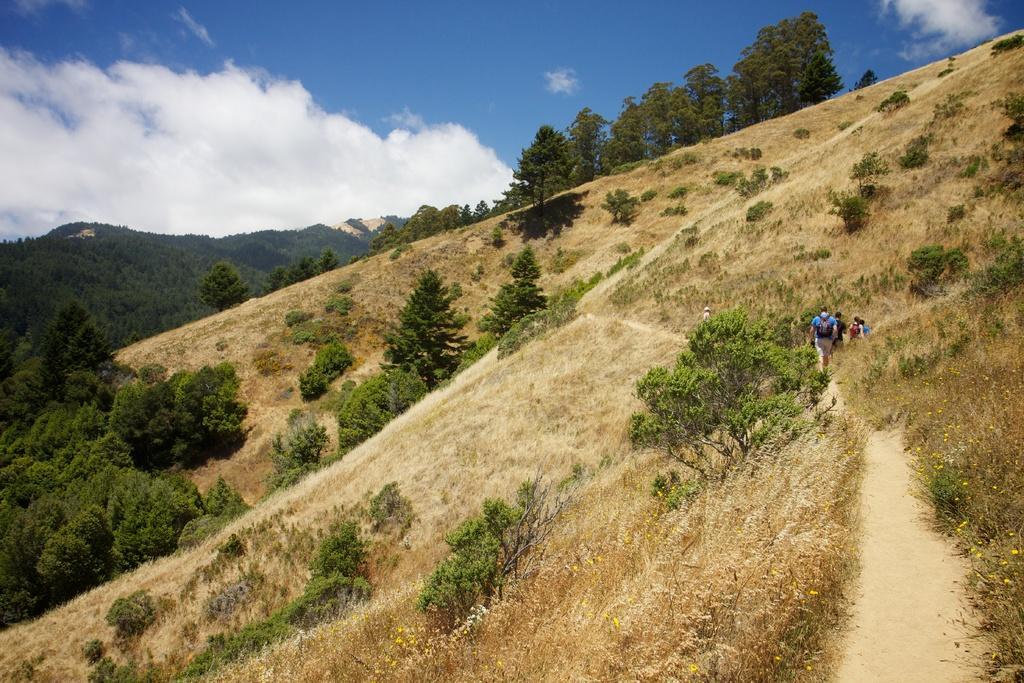In one or two sentences, can you explain what this image depicts? In this image, there are few people standing. There are hills, trees, grass and plants. In the background, there is the sky. 